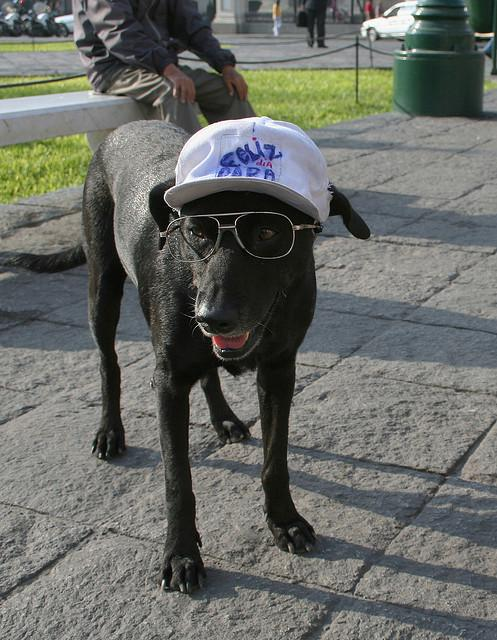What is the dog wearing?

Choices:
A) glasses
B) leash
C) scarf
D) boots glasses 